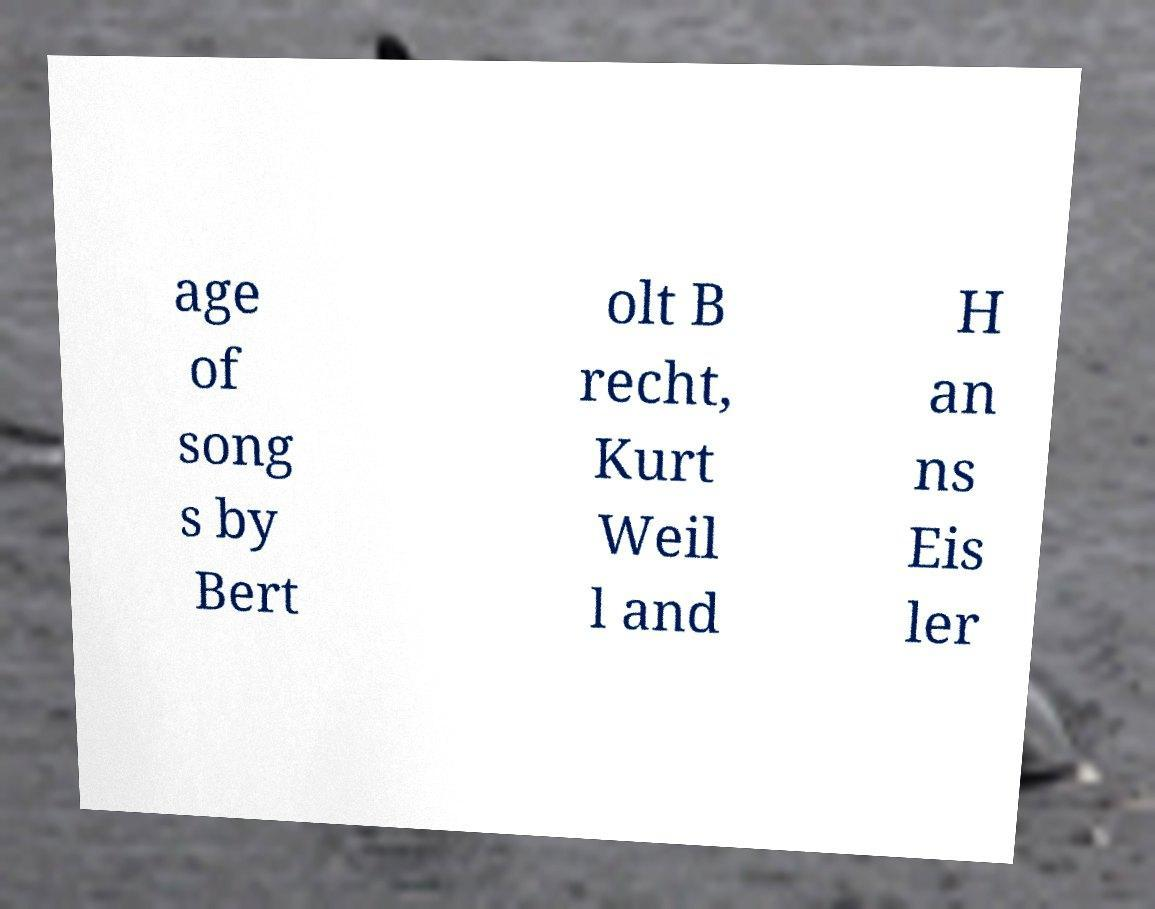Could you assist in decoding the text presented in this image and type it out clearly? age of song s by Bert olt B recht, Kurt Weil l and H an ns Eis ler 